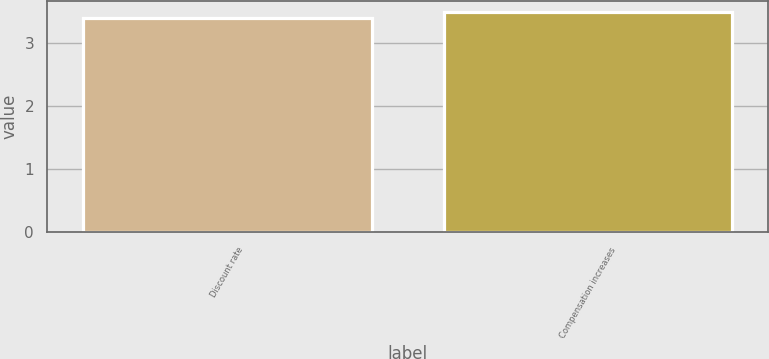Convert chart to OTSL. <chart><loc_0><loc_0><loc_500><loc_500><bar_chart><fcel>Discount rate<fcel>Compensation increases<nl><fcel>3.4<fcel>3.5<nl></chart> 